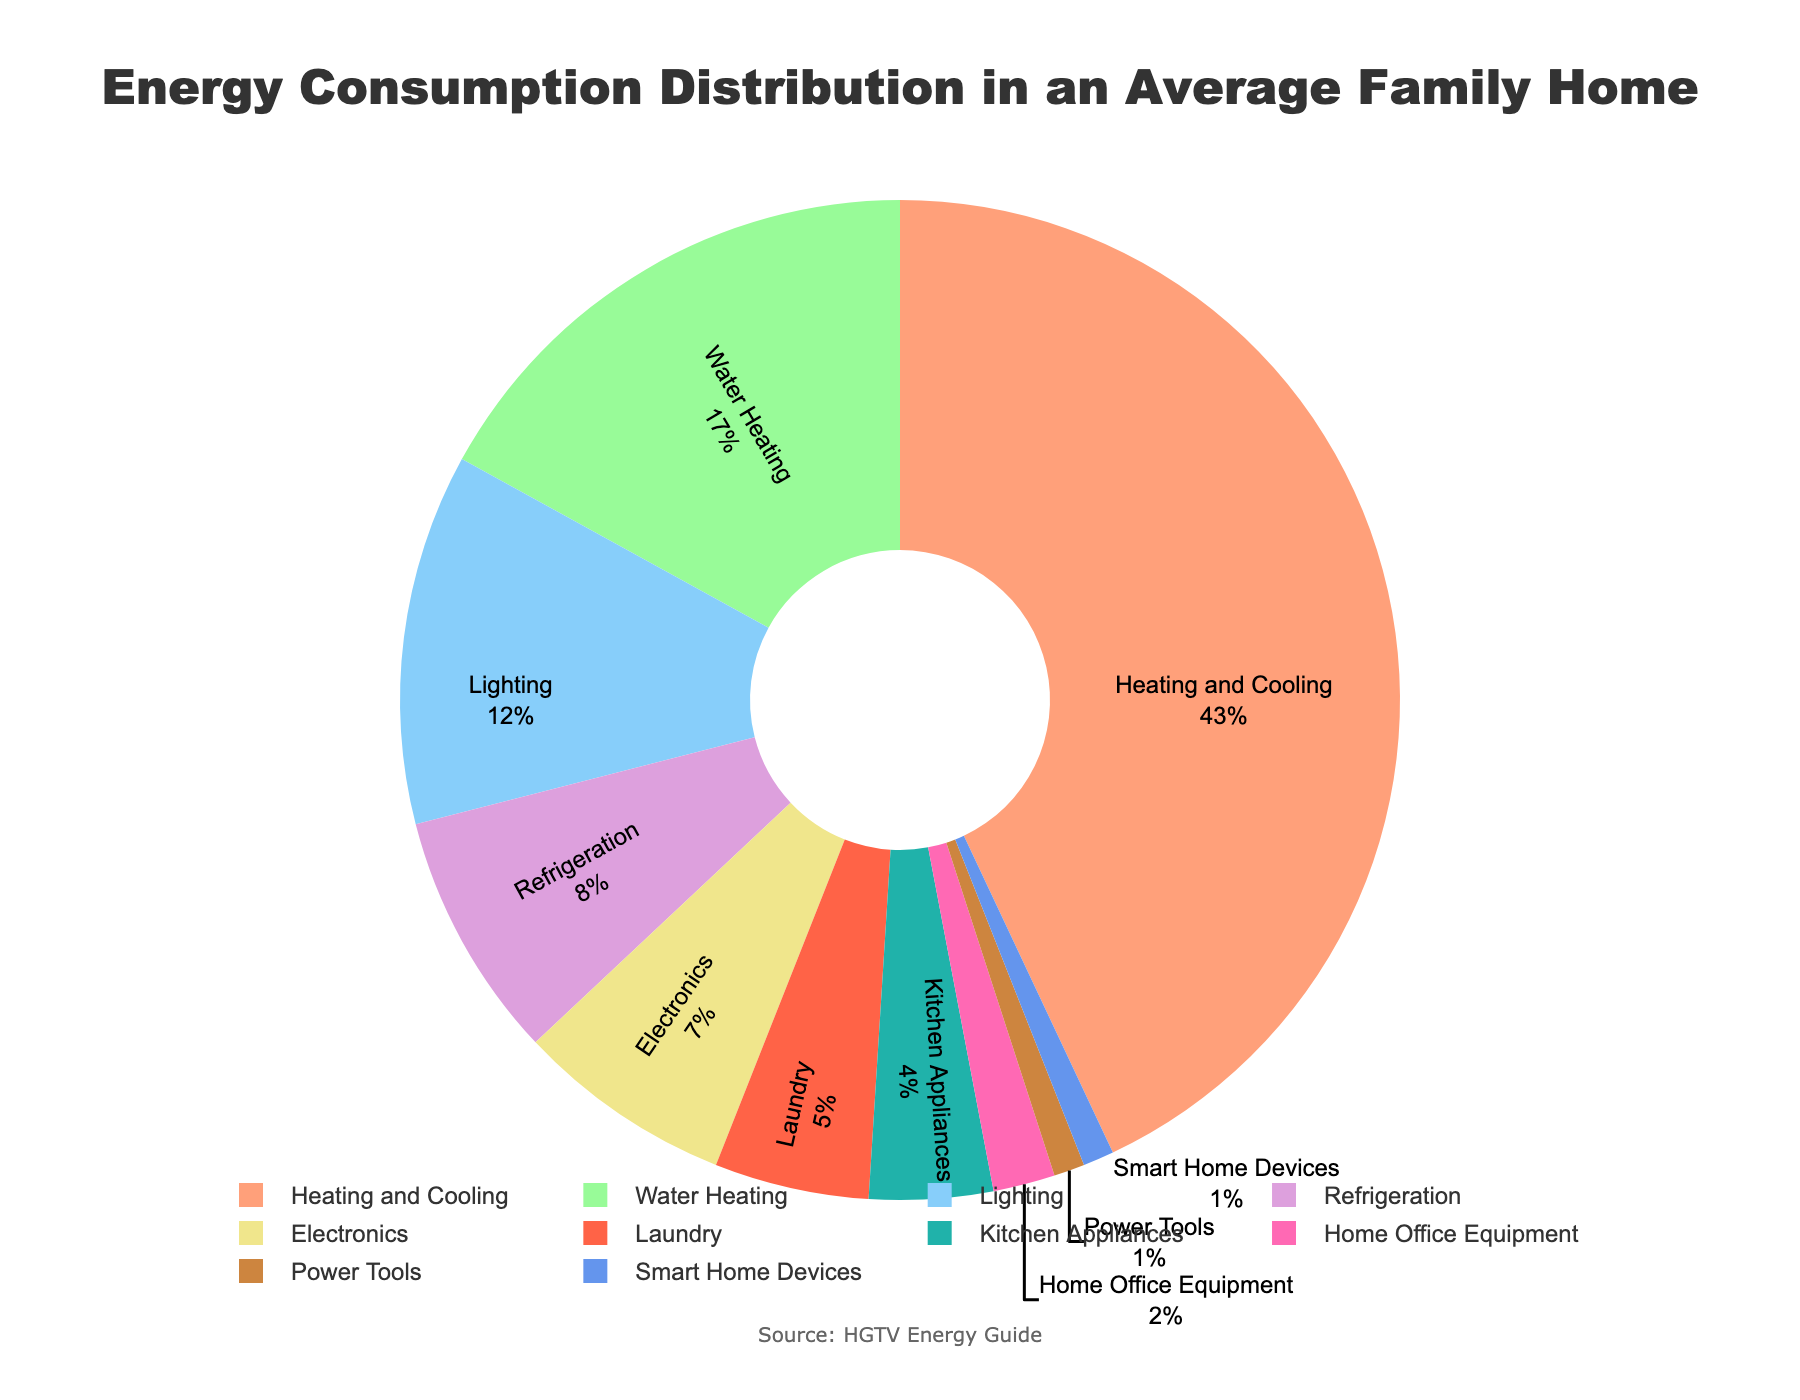what is the category with the highest percentage of energy consumption? The category with the highest percentage of energy consumption is the largest slice in the pie chart. Upon examining the figure, the largest slice corresponds to Heating and Cooling, with 43% of the total energy consumption.
Answer: Heating and Cooling which three categories have the lowest energy consumption percentages? To determine the three categories with the lowest energy consumption percentages, we need to identify the smallest slices in the pie chart. The smallest slices correspond to Home Office Equipment (2%), Power Tools (1%), and Smart Home Devices (1%).
Answer: Home Office Equipment, Power Tools, Smart Home Devices what is the combined percentage of energy consumption for Heating and Cooling and Water Heating? To find the combined percentage, we sum the percentages for Heating and Cooling (43%) and Water Heating (17%). This results in 43% + 17% = 60%.
Answer: 60% how much more energy is consumed by Lighting compared to Electronics? To compare, subtract the percentage for Electronics (7%) from the percentage for Lighting (12%). This results in 12% - 7% = 5%.
Answer: 5% what is the average percentage of energy consumption for Electronics, Laundry, and Kitchen Appliances? To find the average percentage, sum the percentages for Electronics (7%), Laundry (5%), and Kitchen Appliances (4%) and then divide by 3. The sum is 7% + 5% + 4% = 16%, and the average is 16% / 3 ≈ 5.33%.
Answer: 5.33% which category has a higher percentage of energy consumption: Refrigeration or Laundry? Compare the percentages for Refrigeration (8%) and Laundry (5%). Refrigeration has a higher percentage than Laundry.
Answer: Refrigeration what are the colors representing Heating and Cooling and Water Heating in the pie chart? Identifying the colors in the pie chart for Heating and Cooling and Water Heating reveals that Heating and Cooling is represented by the color red, while Water Heating is represented by the color green.
Answer: red and green is the energy consumption percentage for Kitchen Appliances greater than that of Home Office Equipment? Compare the percentages for Kitchen Appliances (4%) and Home Office Equipment (2%). Kitchen Appliances has a greater percentage than Home Office Equipment.
Answer: Yes 